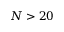Convert formula to latex. <formula><loc_0><loc_0><loc_500><loc_500>N > 2 0</formula> 